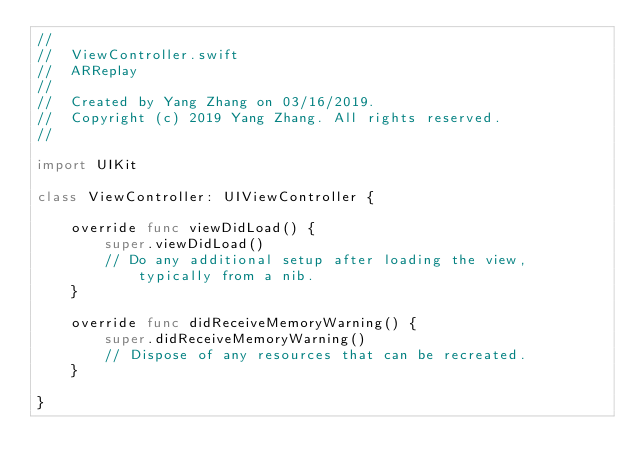Convert code to text. <code><loc_0><loc_0><loc_500><loc_500><_Swift_>//
//  ViewController.swift
//  ARReplay
//
//  Created by Yang Zhang on 03/16/2019.
//  Copyright (c) 2019 Yang Zhang. All rights reserved.
//

import UIKit

class ViewController: UIViewController {

    override func viewDidLoad() {
        super.viewDidLoad()
        // Do any additional setup after loading the view, typically from a nib.
    }

    override func didReceiveMemoryWarning() {
        super.didReceiveMemoryWarning()
        // Dispose of any resources that can be recreated.
    }

}

</code> 